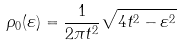<formula> <loc_0><loc_0><loc_500><loc_500>\rho _ { 0 } ( \varepsilon ) = \frac { 1 } { 2 \pi t ^ { 2 } } \sqrt { 4 t ^ { 2 } - \varepsilon ^ { 2 } }</formula> 